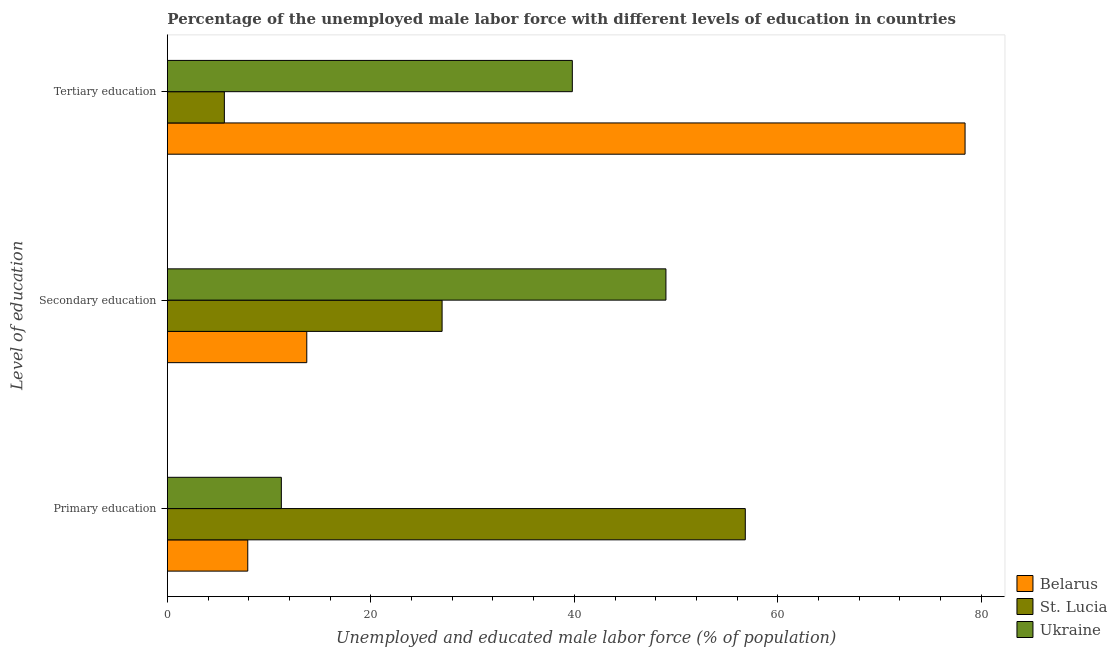How many different coloured bars are there?
Ensure brevity in your answer.  3. How many bars are there on the 3rd tick from the bottom?
Make the answer very short. 3. What is the label of the 2nd group of bars from the top?
Your answer should be very brief. Secondary education. What is the percentage of male labor force who received tertiary education in St. Lucia?
Your answer should be compact. 5.6. Across all countries, what is the maximum percentage of male labor force who received primary education?
Keep it short and to the point. 56.8. Across all countries, what is the minimum percentage of male labor force who received secondary education?
Your answer should be very brief. 13.7. In which country was the percentage of male labor force who received primary education maximum?
Your answer should be compact. St. Lucia. In which country was the percentage of male labor force who received tertiary education minimum?
Offer a very short reply. St. Lucia. What is the total percentage of male labor force who received secondary education in the graph?
Provide a succinct answer. 89.7. What is the difference between the percentage of male labor force who received primary education in St. Lucia and that in Belarus?
Provide a succinct answer. 48.9. What is the difference between the percentage of male labor force who received secondary education in St. Lucia and the percentage of male labor force who received primary education in Belarus?
Your answer should be compact. 19.1. What is the average percentage of male labor force who received secondary education per country?
Your response must be concise. 29.9. What is the difference between the percentage of male labor force who received secondary education and percentage of male labor force who received tertiary education in St. Lucia?
Your answer should be very brief. 21.4. What is the ratio of the percentage of male labor force who received secondary education in St. Lucia to that in Belarus?
Offer a terse response. 1.97. Is the difference between the percentage of male labor force who received secondary education in Ukraine and Belarus greater than the difference between the percentage of male labor force who received tertiary education in Ukraine and Belarus?
Your answer should be very brief. Yes. What is the difference between the highest and the second highest percentage of male labor force who received primary education?
Your answer should be compact. 45.6. What is the difference between the highest and the lowest percentage of male labor force who received primary education?
Your answer should be very brief. 48.9. In how many countries, is the percentage of male labor force who received secondary education greater than the average percentage of male labor force who received secondary education taken over all countries?
Your response must be concise. 1. Is the sum of the percentage of male labor force who received secondary education in Ukraine and Belarus greater than the maximum percentage of male labor force who received tertiary education across all countries?
Provide a short and direct response. No. What does the 2nd bar from the top in Tertiary education represents?
Provide a succinct answer. St. Lucia. What does the 3rd bar from the bottom in Tertiary education represents?
Make the answer very short. Ukraine. Are all the bars in the graph horizontal?
Provide a succinct answer. Yes. Are the values on the major ticks of X-axis written in scientific E-notation?
Your answer should be compact. No. Does the graph contain any zero values?
Your answer should be very brief. No. Does the graph contain grids?
Provide a short and direct response. No. How many legend labels are there?
Your answer should be very brief. 3. What is the title of the graph?
Keep it short and to the point. Percentage of the unemployed male labor force with different levels of education in countries. What is the label or title of the X-axis?
Provide a short and direct response. Unemployed and educated male labor force (% of population). What is the label or title of the Y-axis?
Your response must be concise. Level of education. What is the Unemployed and educated male labor force (% of population) of Belarus in Primary education?
Offer a terse response. 7.9. What is the Unemployed and educated male labor force (% of population) of St. Lucia in Primary education?
Make the answer very short. 56.8. What is the Unemployed and educated male labor force (% of population) of Ukraine in Primary education?
Offer a very short reply. 11.2. What is the Unemployed and educated male labor force (% of population) of Belarus in Secondary education?
Provide a succinct answer. 13.7. What is the Unemployed and educated male labor force (% of population) in St. Lucia in Secondary education?
Give a very brief answer. 27. What is the Unemployed and educated male labor force (% of population) in Belarus in Tertiary education?
Give a very brief answer. 78.4. What is the Unemployed and educated male labor force (% of population) in St. Lucia in Tertiary education?
Provide a succinct answer. 5.6. What is the Unemployed and educated male labor force (% of population) in Ukraine in Tertiary education?
Keep it short and to the point. 39.8. Across all Level of education, what is the maximum Unemployed and educated male labor force (% of population) of Belarus?
Provide a succinct answer. 78.4. Across all Level of education, what is the maximum Unemployed and educated male labor force (% of population) in St. Lucia?
Offer a very short reply. 56.8. Across all Level of education, what is the maximum Unemployed and educated male labor force (% of population) in Ukraine?
Make the answer very short. 49. Across all Level of education, what is the minimum Unemployed and educated male labor force (% of population) in Belarus?
Your answer should be compact. 7.9. Across all Level of education, what is the minimum Unemployed and educated male labor force (% of population) in St. Lucia?
Your response must be concise. 5.6. Across all Level of education, what is the minimum Unemployed and educated male labor force (% of population) in Ukraine?
Give a very brief answer. 11.2. What is the total Unemployed and educated male labor force (% of population) in Belarus in the graph?
Your response must be concise. 100. What is the total Unemployed and educated male labor force (% of population) of St. Lucia in the graph?
Offer a terse response. 89.4. What is the total Unemployed and educated male labor force (% of population) in Ukraine in the graph?
Provide a succinct answer. 100. What is the difference between the Unemployed and educated male labor force (% of population) in Belarus in Primary education and that in Secondary education?
Provide a short and direct response. -5.8. What is the difference between the Unemployed and educated male labor force (% of population) in St. Lucia in Primary education and that in Secondary education?
Offer a very short reply. 29.8. What is the difference between the Unemployed and educated male labor force (% of population) of Ukraine in Primary education and that in Secondary education?
Make the answer very short. -37.8. What is the difference between the Unemployed and educated male labor force (% of population) of Belarus in Primary education and that in Tertiary education?
Provide a short and direct response. -70.5. What is the difference between the Unemployed and educated male labor force (% of population) in St. Lucia in Primary education and that in Tertiary education?
Make the answer very short. 51.2. What is the difference between the Unemployed and educated male labor force (% of population) in Ukraine in Primary education and that in Tertiary education?
Provide a succinct answer. -28.6. What is the difference between the Unemployed and educated male labor force (% of population) in Belarus in Secondary education and that in Tertiary education?
Offer a terse response. -64.7. What is the difference between the Unemployed and educated male labor force (% of population) of St. Lucia in Secondary education and that in Tertiary education?
Make the answer very short. 21.4. What is the difference between the Unemployed and educated male labor force (% of population) in Ukraine in Secondary education and that in Tertiary education?
Your answer should be very brief. 9.2. What is the difference between the Unemployed and educated male labor force (% of population) in Belarus in Primary education and the Unemployed and educated male labor force (% of population) in St. Lucia in Secondary education?
Keep it short and to the point. -19.1. What is the difference between the Unemployed and educated male labor force (% of population) of Belarus in Primary education and the Unemployed and educated male labor force (% of population) of Ukraine in Secondary education?
Your response must be concise. -41.1. What is the difference between the Unemployed and educated male labor force (% of population) of Belarus in Primary education and the Unemployed and educated male labor force (% of population) of Ukraine in Tertiary education?
Your response must be concise. -31.9. What is the difference between the Unemployed and educated male labor force (% of population) in St. Lucia in Primary education and the Unemployed and educated male labor force (% of population) in Ukraine in Tertiary education?
Make the answer very short. 17. What is the difference between the Unemployed and educated male labor force (% of population) of Belarus in Secondary education and the Unemployed and educated male labor force (% of population) of Ukraine in Tertiary education?
Your response must be concise. -26.1. What is the average Unemployed and educated male labor force (% of population) of Belarus per Level of education?
Ensure brevity in your answer.  33.33. What is the average Unemployed and educated male labor force (% of population) of St. Lucia per Level of education?
Your answer should be compact. 29.8. What is the average Unemployed and educated male labor force (% of population) of Ukraine per Level of education?
Give a very brief answer. 33.33. What is the difference between the Unemployed and educated male labor force (% of population) in Belarus and Unemployed and educated male labor force (% of population) in St. Lucia in Primary education?
Your response must be concise. -48.9. What is the difference between the Unemployed and educated male labor force (% of population) in St. Lucia and Unemployed and educated male labor force (% of population) in Ukraine in Primary education?
Keep it short and to the point. 45.6. What is the difference between the Unemployed and educated male labor force (% of population) of Belarus and Unemployed and educated male labor force (% of population) of Ukraine in Secondary education?
Ensure brevity in your answer.  -35.3. What is the difference between the Unemployed and educated male labor force (% of population) of Belarus and Unemployed and educated male labor force (% of population) of St. Lucia in Tertiary education?
Ensure brevity in your answer.  72.8. What is the difference between the Unemployed and educated male labor force (% of population) of Belarus and Unemployed and educated male labor force (% of population) of Ukraine in Tertiary education?
Your answer should be compact. 38.6. What is the difference between the Unemployed and educated male labor force (% of population) of St. Lucia and Unemployed and educated male labor force (% of population) of Ukraine in Tertiary education?
Provide a short and direct response. -34.2. What is the ratio of the Unemployed and educated male labor force (% of population) in Belarus in Primary education to that in Secondary education?
Your response must be concise. 0.58. What is the ratio of the Unemployed and educated male labor force (% of population) of St. Lucia in Primary education to that in Secondary education?
Provide a short and direct response. 2.1. What is the ratio of the Unemployed and educated male labor force (% of population) in Ukraine in Primary education to that in Secondary education?
Your answer should be very brief. 0.23. What is the ratio of the Unemployed and educated male labor force (% of population) in Belarus in Primary education to that in Tertiary education?
Provide a succinct answer. 0.1. What is the ratio of the Unemployed and educated male labor force (% of population) in St. Lucia in Primary education to that in Tertiary education?
Offer a very short reply. 10.14. What is the ratio of the Unemployed and educated male labor force (% of population) in Ukraine in Primary education to that in Tertiary education?
Keep it short and to the point. 0.28. What is the ratio of the Unemployed and educated male labor force (% of population) in Belarus in Secondary education to that in Tertiary education?
Give a very brief answer. 0.17. What is the ratio of the Unemployed and educated male labor force (% of population) of St. Lucia in Secondary education to that in Tertiary education?
Provide a succinct answer. 4.82. What is the ratio of the Unemployed and educated male labor force (% of population) of Ukraine in Secondary education to that in Tertiary education?
Keep it short and to the point. 1.23. What is the difference between the highest and the second highest Unemployed and educated male labor force (% of population) of Belarus?
Ensure brevity in your answer.  64.7. What is the difference between the highest and the second highest Unemployed and educated male labor force (% of population) of St. Lucia?
Your response must be concise. 29.8. What is the difference between the highest and the lowest Unemployed and educated male labor force (% of population) in Belarus?
Ensure brevity in your answer.  70.5. What is the difference between the highest and the lowest Unemployed and educated male labor force (% of population) in St. Lucia?
Ensure brevity in your answer.  51.2. What is the difference between the highest and the lowest Unemployed and educated male labor force (% of population) of Ukraine?
Your response must be concise. 37.8. 